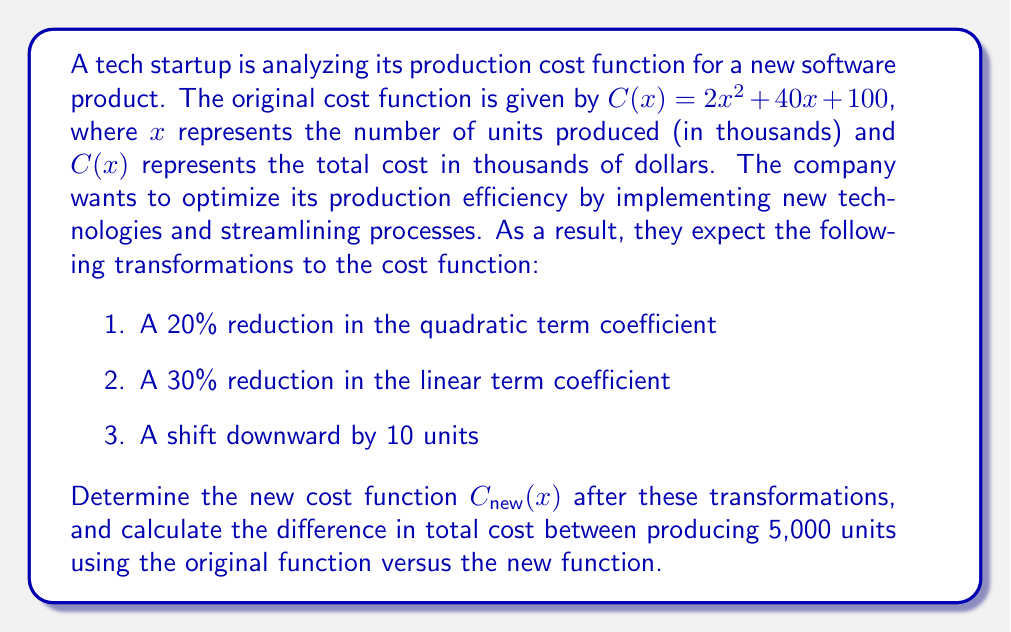What is the answer to this math problem? Let's approach this step-by-step:

1. Original cost function:
   $C(x) = 2x^2 + 40x + 100$

2. Apply the transformations:
   a) 20% reduction in the quadratic term coefficient:
      $2 * (1 - 0.20) = 1.6$
   
   b) 30% reduction in the linear term coefficient:
      $40 * (1 - 0.30) = 28$
   
   c) Shift downward by 10 units:
      Subtract 10 from the constant term

3. New cost function:
   $C_{new}(x) = 1.6x^2 + 28x + 90$

4. Calculate the cost for 5,000 units (x = 5) using both functions:

   Original function:
   $C(5) = 2(5^2) + 40(5) + 100$
   $= 2(25) + 200 + 100$
   $= 50 + 200 + 100 = 350$

   New function:
   $C_{new}(5) = 1.6(5^2) + 28(5) + 90$
   $= 1.6(25) + 140 + 90$
   $= 40 + 140 + 90 = 270$

5. Calculate the difference:
   Difference = Original cost - New cost
   $= 350 - 270 = 80$

Therefore, the difference in total cost for producing 5,000 units is 80 thousand dollars, with the new function resulting in lower costs.
Answer: The new cost function is $C_{new}(x) = 1.6x^2 + 28x + 90$, and the difference in total cost for producing 5,000 units between the original and new functions is $80,000. 